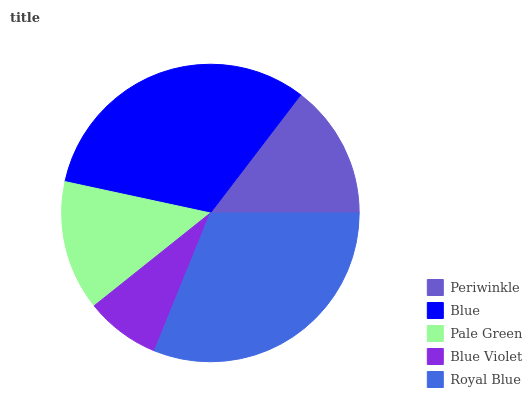Is Blue Violet the minimum?
Answer yes or no. Yes. Is Blue the maximum?
Answer yes or no. Yes. Is Pale Green the minimum?
Answer yes or no. No. Is Pale Green the maximum?
Answer yes or no. No. Is Blue greater than Pale Green?
Answer yes or no. Yes. Is Pale Green less than Blue?
Answer yes or no. Yes. Is Pale Green greater than Blue?
Answer yes or no. No. Is Blue less than Pale Green?
Answer yes or no. No. Is Periwinkle the high median?
Answer yes or no. Yes. Is Periwinkle the low median?
Answer yes or no. Yes. Is Blue the high median?
Answer yes or no. No. Is Blue Violet the low median?
Answer yes or no. No. 